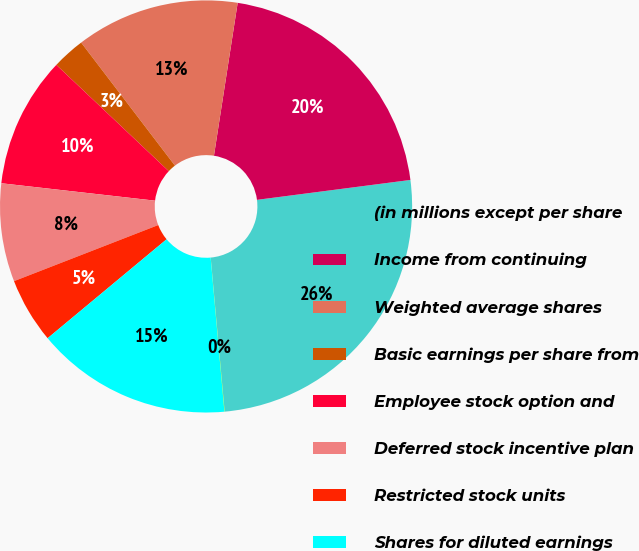Convert chart. <chart><loc_0><loc_0><loc_500><loc_500><pie_chart><fcel>(in millions except per share<fcel>Income from continuing<fcel>Weighted average shares<fcel>Basic earnings per share from<fcel>Employee stock option and<fcel>Deferred stock incentive plan<fcel>Restricted stock units<fcel>Shares for diluted earnings<fcel>Diluted earnings per share<nl><fcel>25.62%<fcel>20.5%<fcel>12.82%<fcel>2.58%<fcel>10.26%<fcel>7.7%<fcel>5.14%<fcel>15.38%<fcel>0.02%<nl></chart> 